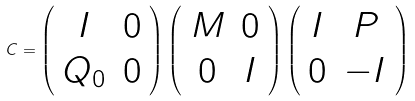Convert formula to latex. <formula><loc_0><loc_0><loc_500><loc_500>C = \left ( \begin{array} { c c } I & 0 \\ Q _ { 0 } & 0 \end{array} \right ) \left ( \begin{array} { c c } M & 0 \\ 0 & I \end{array} \right ) \left ( \begin{array} { c c } I & P \\ 0 & - I \end{array} \right )</formula> 